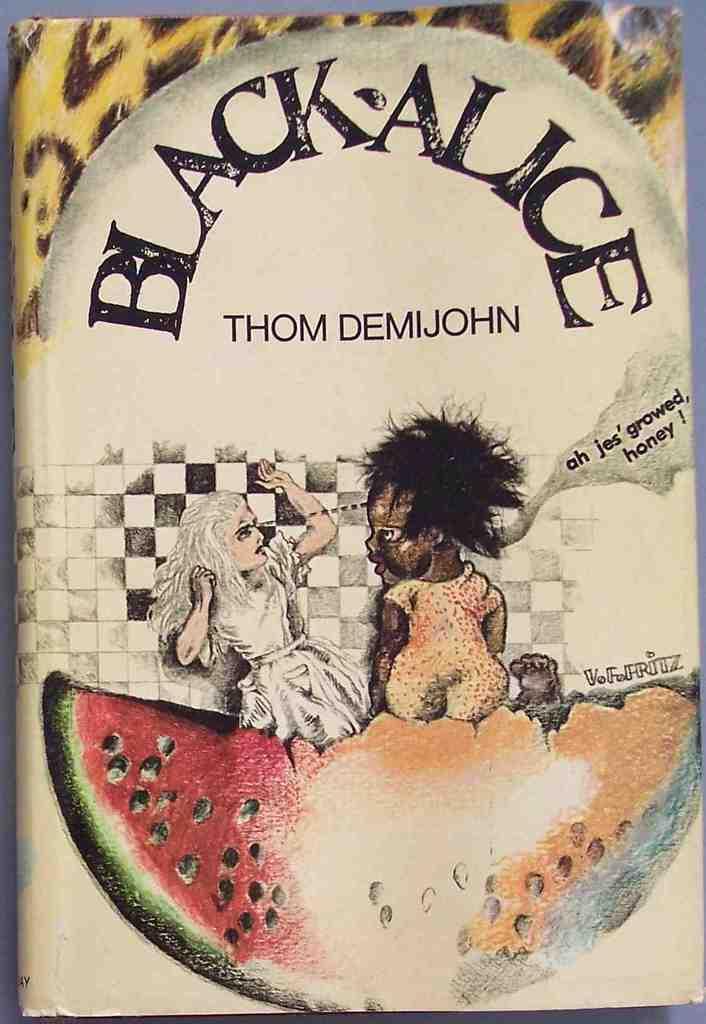Can you describe this image briefly? In this picture I can observe cover page of a book. There is some text in this cover page. I can observe a fruit which is looking like a watermelon in the bottom of the picture. 